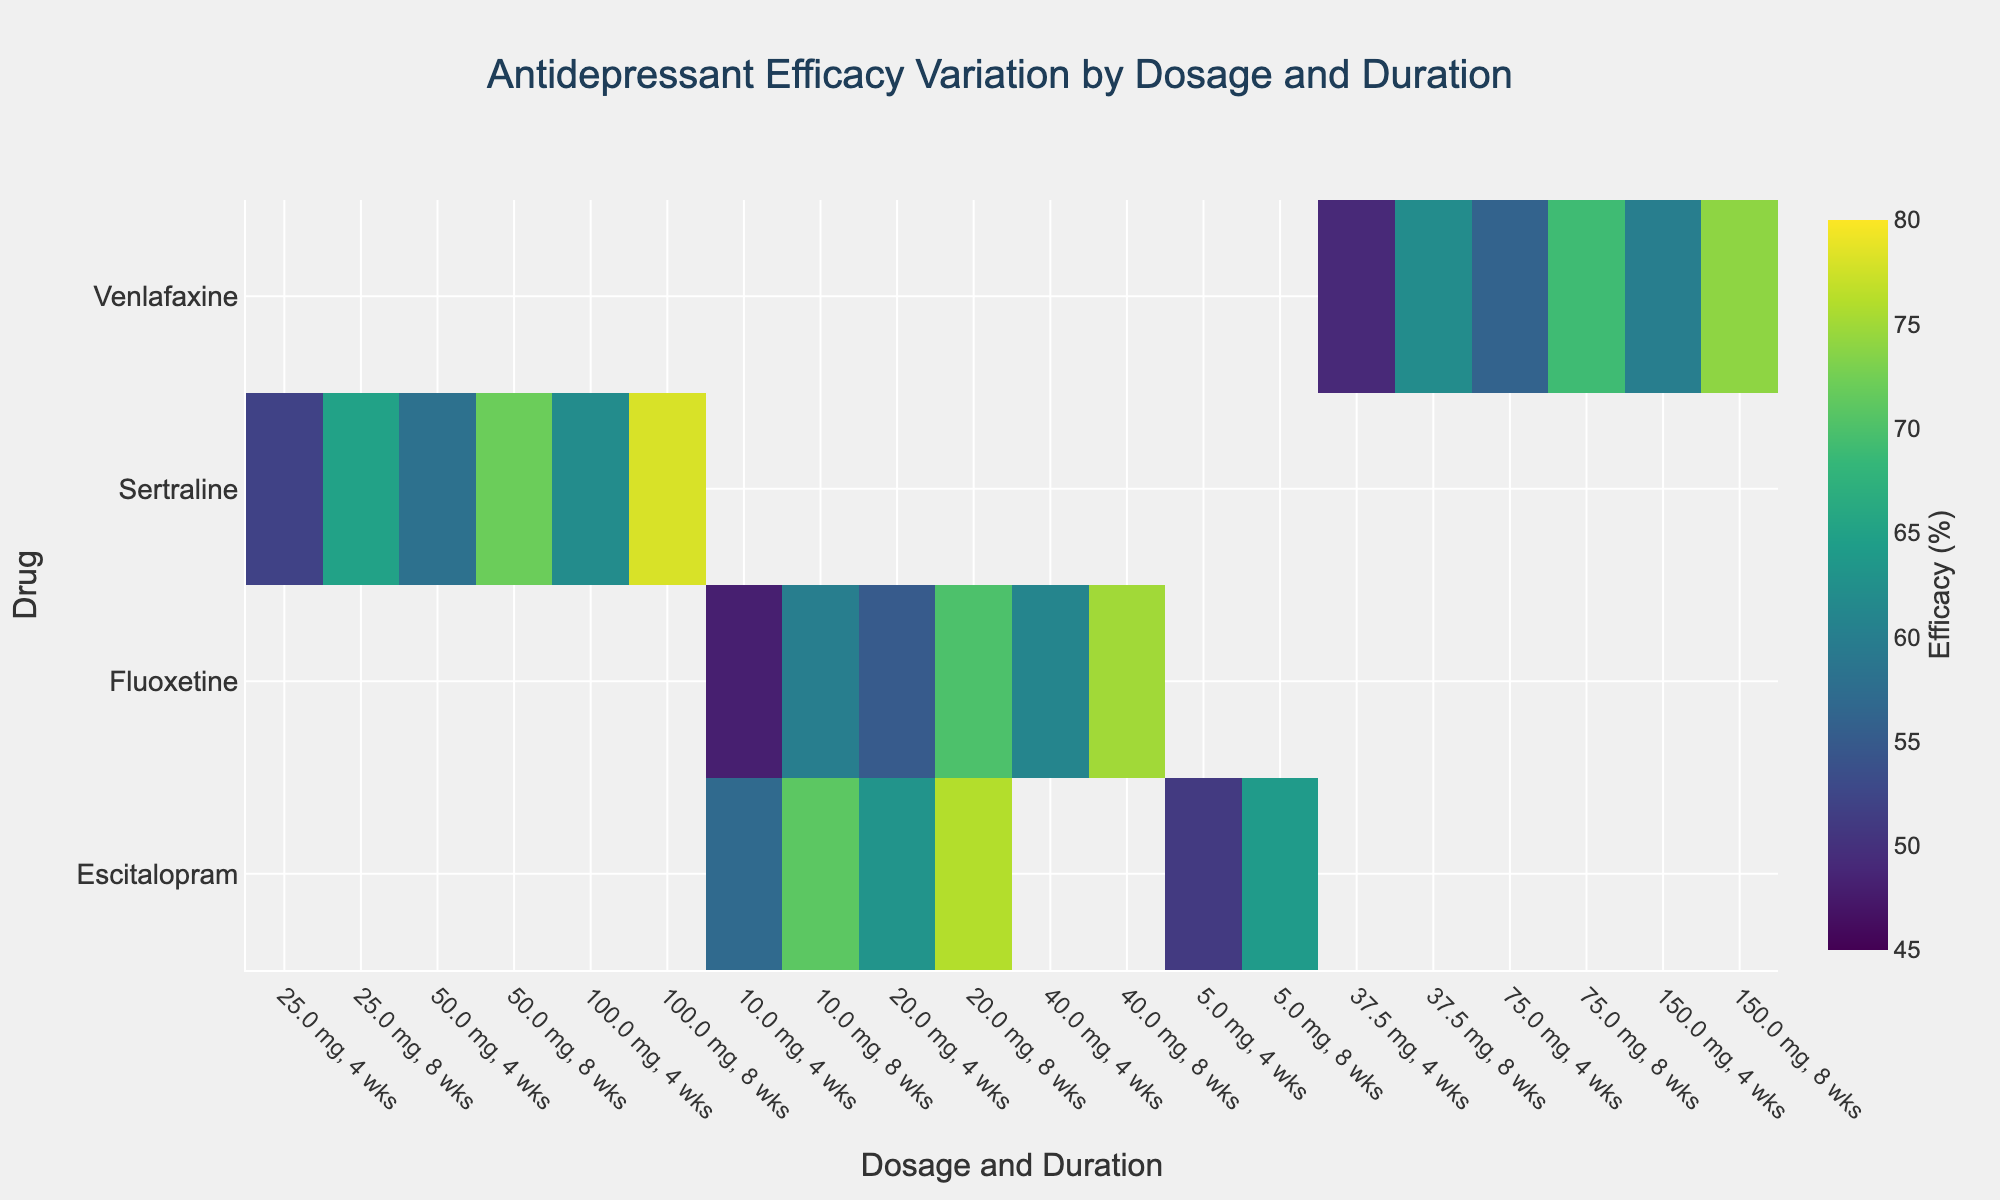What is the title of the heatmap? The title of the heatmap is usually located at the top of the figure and formatted in a larger font size. In this case, the title is "Antidepressant Efficacy Variation by Dosage and Duration."
Answer: Antidepressant Efficacy Variation by Dosage and Duration What are the axes labels in the heatmap? Axes labels describe the categories being measured. For this heatmap, the x-axis shows "Dosage and Duration," and the y-axis shows "Drug."
Answer: Dosage and Duration; Drug Which antidepressant has the highest efficacy after 8 weeks at the highest dosage? To determine this, scan down the 8-week duration columns for the highest dosage of each drug and find the highest efficacy percentage. For example, Sertraline at 100 mg/day for 8 weeks has an efficacy of 78%, Fluoxetine at 40 mg/day for 8 weeks has 75%, Escitalopram at 20 mg/day for 8 weeks has 76%, and Venlafaxine at 150 mg/day for 8 weeks has 74%. The highest value is 78% for Sertraline.
Answer: Sertraline Which dosage and duration combination yields the lowest efficacy for Fluoxetine? Identify all Fluoxetine entries and find the combination with the lowest efficacy percentage. For Fluoxetine, look at the combinations: 10 mg/day, 4 weeks yields 48%; 10 mg/day, 8 weeks 60%; 20 mg/day, 4 weeks 55%; 20 mg/day, 8 weeks 70%; 40 mg/day, 4 weeks 61%; and 40 mg/day, 8 weeks 75%. The lowest is 48% for 10 mg/day, 4 weeks.
Answer: 10 mg/day, 4 weeks Compare the efficacy of Escitalopram at 10 mg/day after 4 weeks to its efficacy after 8 weeks. Find the efficacy percentages for Escitalopram at 10 mg/day for both 4 and 8 weeks. For 4 weeks, it's 57%, and for 8 weeks, it's 71%. The efficacy increases by 14% after 8 weeks.
Answer: 57% vs. 71% Which drug shows the most significant increase in efficacy between 4 weeks and 8 weeks at the same dosage? Calculate the differences in efficacy between 4-week and 8-week durations for each drug at their different dosages. Determine which shows the largest increase. For Sertraline, the maximum increase is 16%; for Fluoxetine, it's 15%; for Escitalopram, it's 14%; and for Venlafaxine, it's 13%. The largest increase is 16% for Sertraline.
Answer: Sertraline Does Venlafaxine have an efficacy greater than 60% at the lowest dosage for the 4-week duration? Identify the efficacy of Venlafaxine at the lowest dosage (37.5 mg/day) for a 4-week duration. The heatmap shows an efficacy of 49%. Hence, it does not exceed 60%.
Answer: No Which combination for Sertraline yields the highest efficacy? Locate the maximum efficacy percentage for Sertraline across all dosage and duration combinations. The values to compare are 52%, 65%, 58%, 72%, 62%, and 78%. The highest is 78% at 100 mg/day, 8 weeks.
Answer: 100 mg/day, 8 weeks How many unique dosage and duration combinations are evaluated in the heatmap for Escitalopram? For Escitalopram, count the unique combinations. These are 5 mg/day for 4 and 8 weeks, 10 mg/day for 4 and 8 weeks, and 20 mg/day for 4 and 8 weeks, resulting in 6 unique combinations.
Answer: 6 